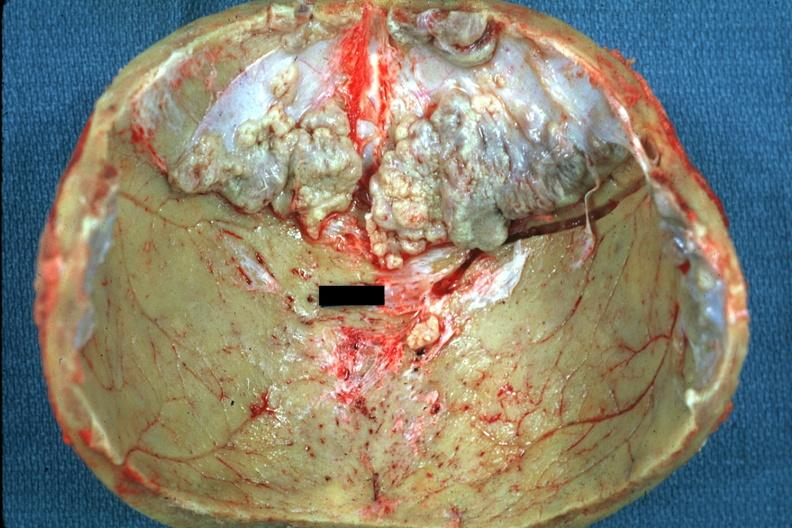s bone, calvarium present?
Answer the question using a single word or phrase. Yes 